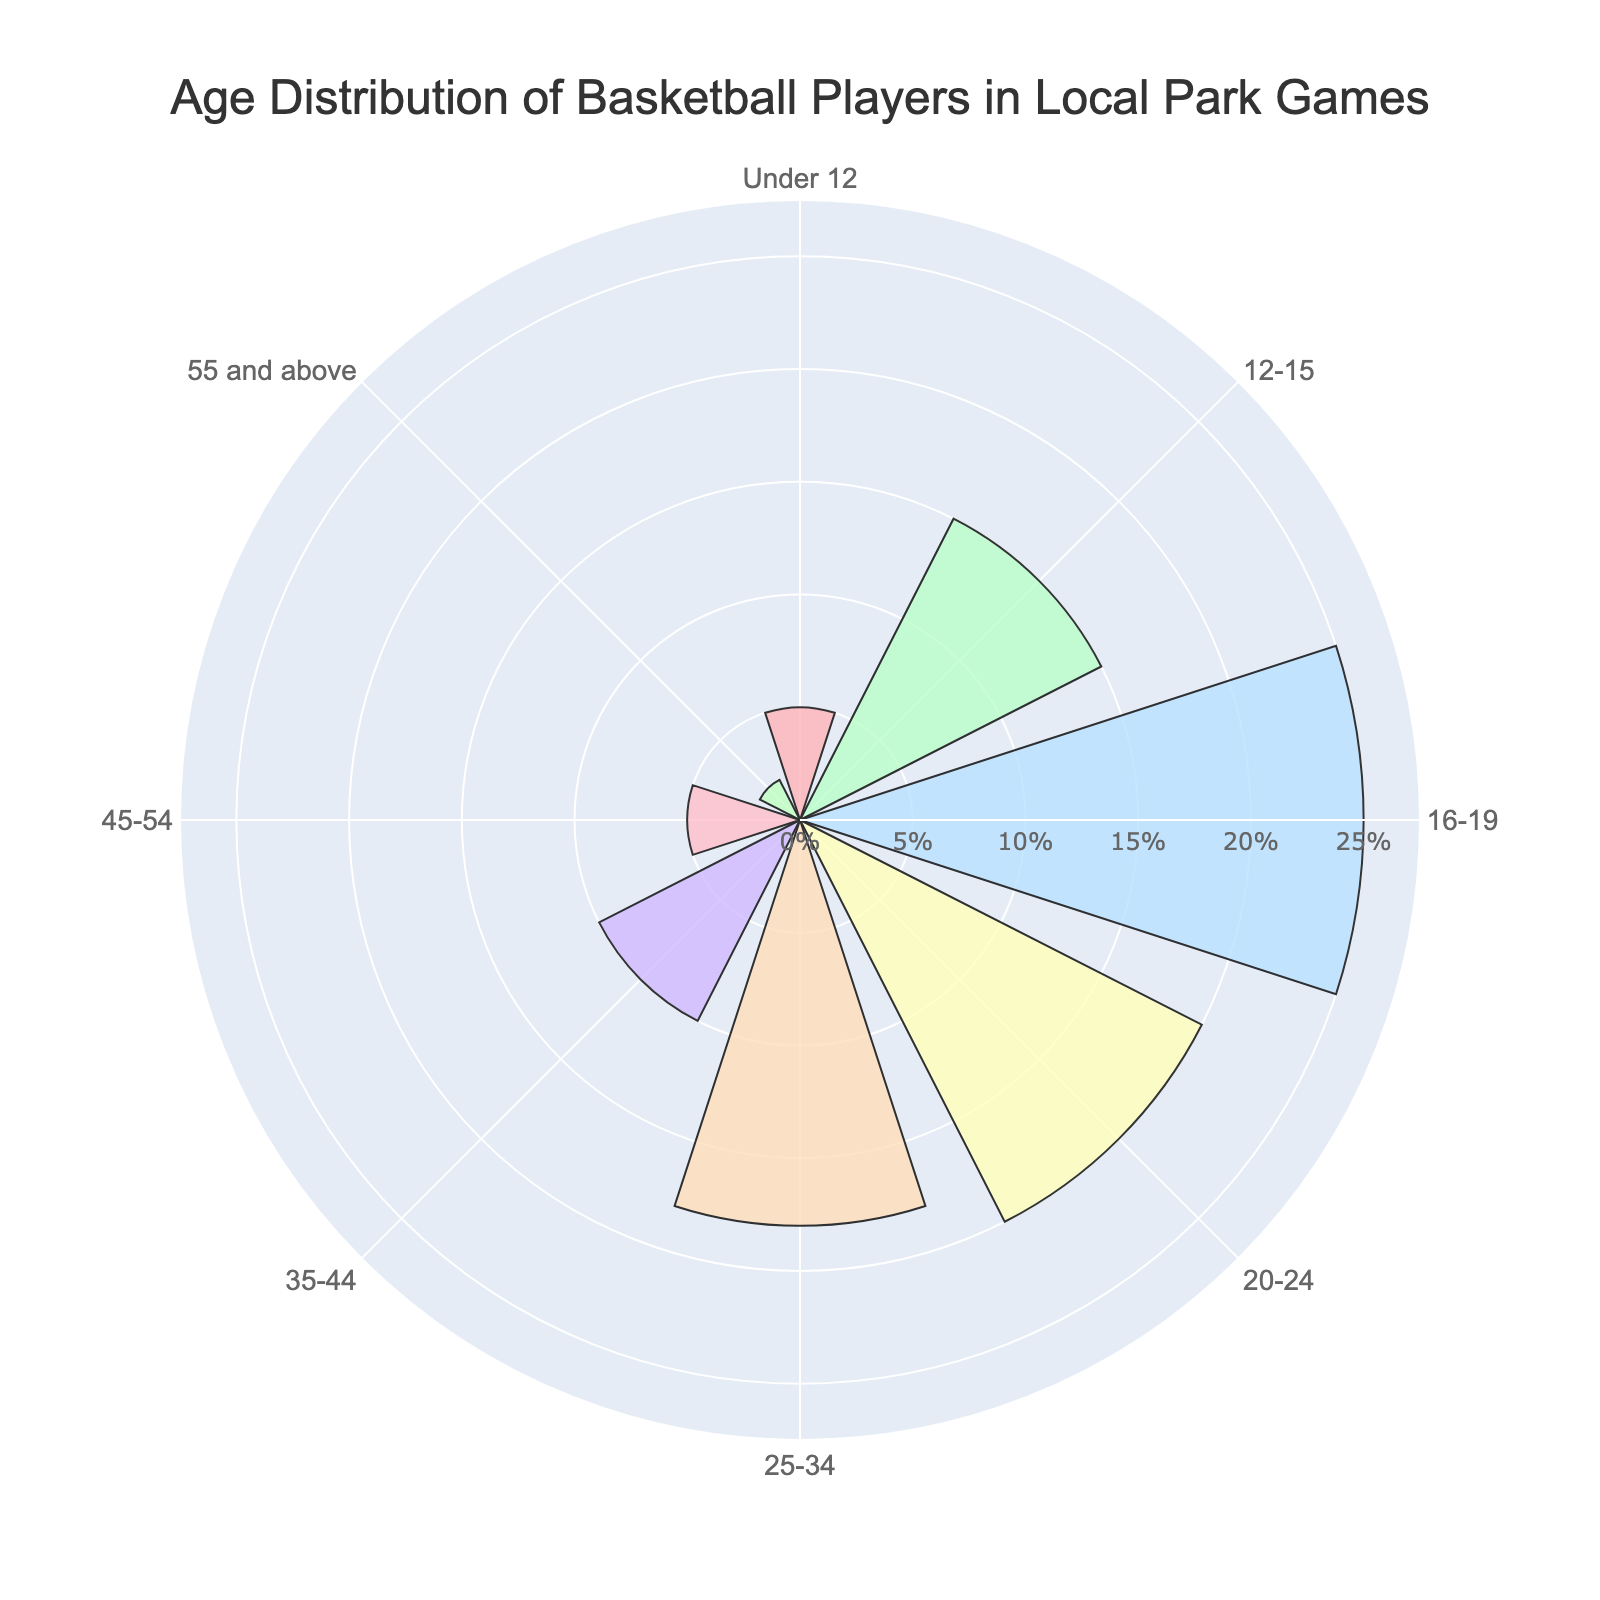What is the title of the chart? The title is usually written at the top of the chart and it describes what the chart is about.
Answer: Age Distribution of Basketball Players in Local Park Games Which age group has the highest percentage of players? The bars' length represents the percentage, and the longest bar corresponds to the highest percentage.
Answer: 16-19 What's the total percentage of players who are younger than 20 years old? Sum the percentages of the age groups Under 12, 12-15, and 16-19.
Answer: 45% What is the percentage difference between players aged 25-34 and players aged 55 and above? Subtract the percentage of the 55 and above group from the 25-34 group.
Answer: 16% Between which two consecutive age groups is there the largest drop in percentage? Compare the differences between consecutive age groups and identify the largest one.
Answer: 45-54 and 55 and above What is the average percentage of players in the age groups 16-19, 20-24, and 25-34? Add the percentages of these groups and divide by the number of groups.
Answer: 21% Which age groups have the same percentage of players? Identify age groups with equal bar lengths.
Answer: Under 12 and 45-54 Are there more players aged 12-15 or aged 35-44? Compare the bars' lengths for these age groups to see which one is longer.
Answer: 12-15 What is the combined percentage of all age groups above 35? Sum the percentages of the 35-44, 45-54, and 55 and above age groups.
Answer: 17% How many age groups have a percentage above 15%? Count the number of bars that extend beyond the 15% mark.
Answer: 3 